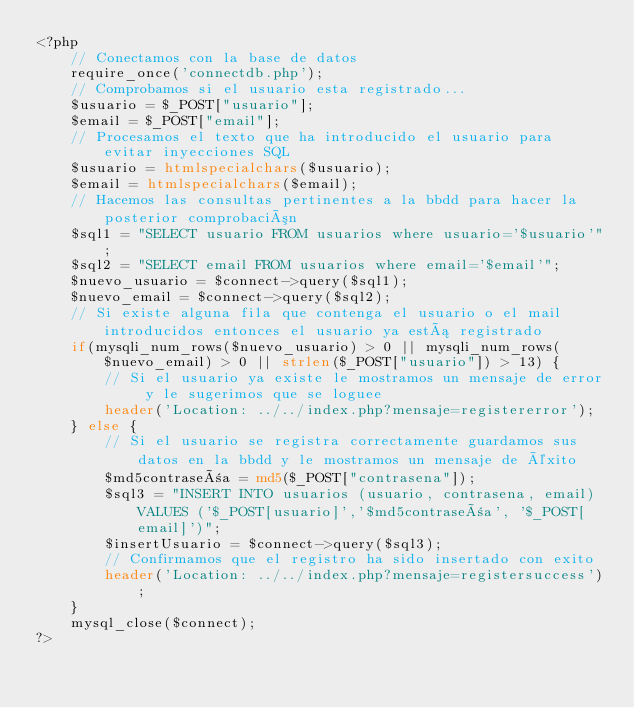<code> <loc_0><loc_0><loc_500><loc_500><_PHP_><?php
	// Conectamos con la base de datos
	require_once('connectdb.php');
	// Comprobamos si el usuario esta registrado...
	$usuario = $_POST["usuario"];
	$email = $_POST["email"];
	// Procesamos el texto que ha introducido el usuario para evitar inyecciones SQL
	$usuario = htmlspecialchars($usuario); 
	$email = htmlspecialchars($email);
	// Hacemos las consultas pertinentes a la bbdd para hacer la posterior comprobación
	$sql1 = "SELECT usuario FROM usuarios where usuario='$usuario'";
	$sql2 = "SELECT email FROM usuarios where email='$email'";
	$nuevo_usuario = $connect->query($sql1);
	$nuevo_email = $connect->query($sql2);
	// Si existe alguna fila que contenga el usuario o el mail introducidos entonces el usuario ya está registrado
	if(mysqli_num_rows($nuevo_usuario) > 0 || mysqli_num_rows($nuevo_email) > 0 || strlen($_POST["usuario"]) > 13) {
		// Si el usuario ya existe le mostramos un mensaje de error y le sugerimos que se loguee
		header('Location: ../../index.php?mensaje=registererror');
	} else {
		// Si el usuario se registra correctamente guardamos sus datos en la bbdd y le mostramos un mensaje de éxito
		$md5contraseña = md5($_POST["contrasena"]);
		$sql3 = "INSERT INTO usuarios (usuario, contrasena, email) VALUES ('$_POST[usuario]','$md5contraseña', '$_POST[email]')";
		$insertUsuario = $connect->query($sql3);
		// Confirmamos que el registro ha sido insertado con exito
		header('Location: ../../index.php?mensaje=registersuccess');
	} 
	mysql_close($connect);
?></code> 